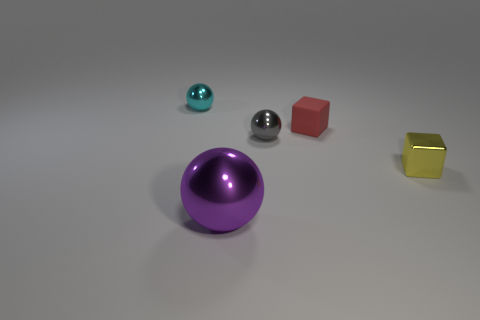Add 1 tiny green blocks. How many objects exist? 6 Subtract all balls. How many objects are left? 2 Add 4 purple metallic spheres. How many purple metallic spheres are left? 5 Add 4 small red things. How many small red things exist? 5 Subtract 0 green spheres. How many objects are left? 5 Subtract all yellow things. Subtract all small gray metallic balls. How many objects are left? 3 